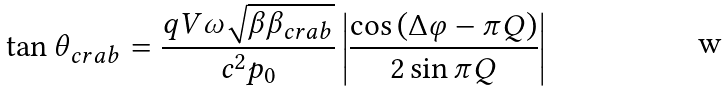<formula> <loc_0><loc_0><loc_500><loc_500>\tan \theta _ { c r a b } = \frac { q V \omega \sqrt { \beta \beta _ { c r a b } } } { c ^ { 2 } p _ { 0 } } \left | \frac { \cos \left ( \Delta \varphi - \pi Q \right ) } { 2 \sin \pi Q } \right |</formula> 